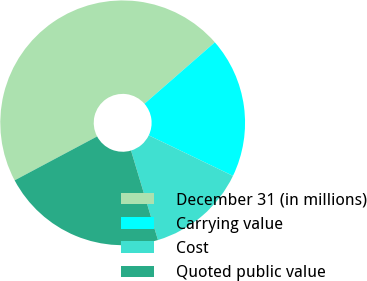Convert chart. <chart><loc_0><loc_0><loc_500><loc_500><pie_chart><fcel>December 31 (in millions)<fcel>Carrying value<fcel>Cost<fcel>Quoted public value<nl><fcel>46.36%<fcel>18.56%<fcel>13.21%<fcel>21.87%<nl></chart> 